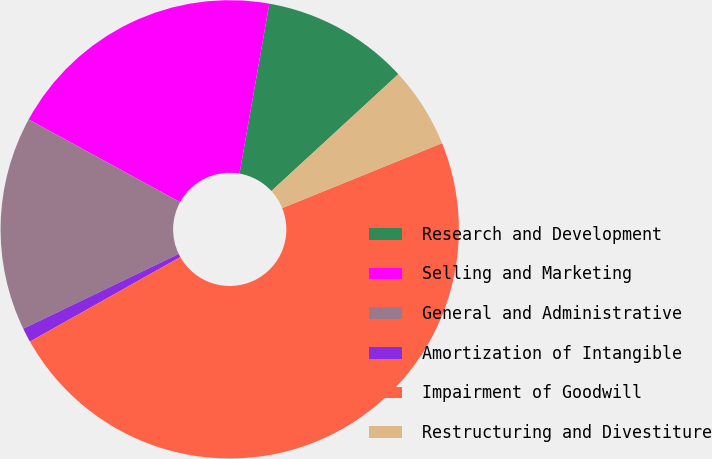<chart> <loc_0><loc_0><loc_500><loc_500><pie_chart><fcel>Research and Development<fcel>Selling and Marketing<fcel>General and Administrative<fcel>Amortization of Intangible<fcel>Impairment of Goodwill<fcel>Restructuring and Divestiture<nl><fcel>10.4%<fcel>19.8%<fcel>15.1%<fcel>1.01%<fcel>47.99%<fcel>5.7%<nl></chart> 